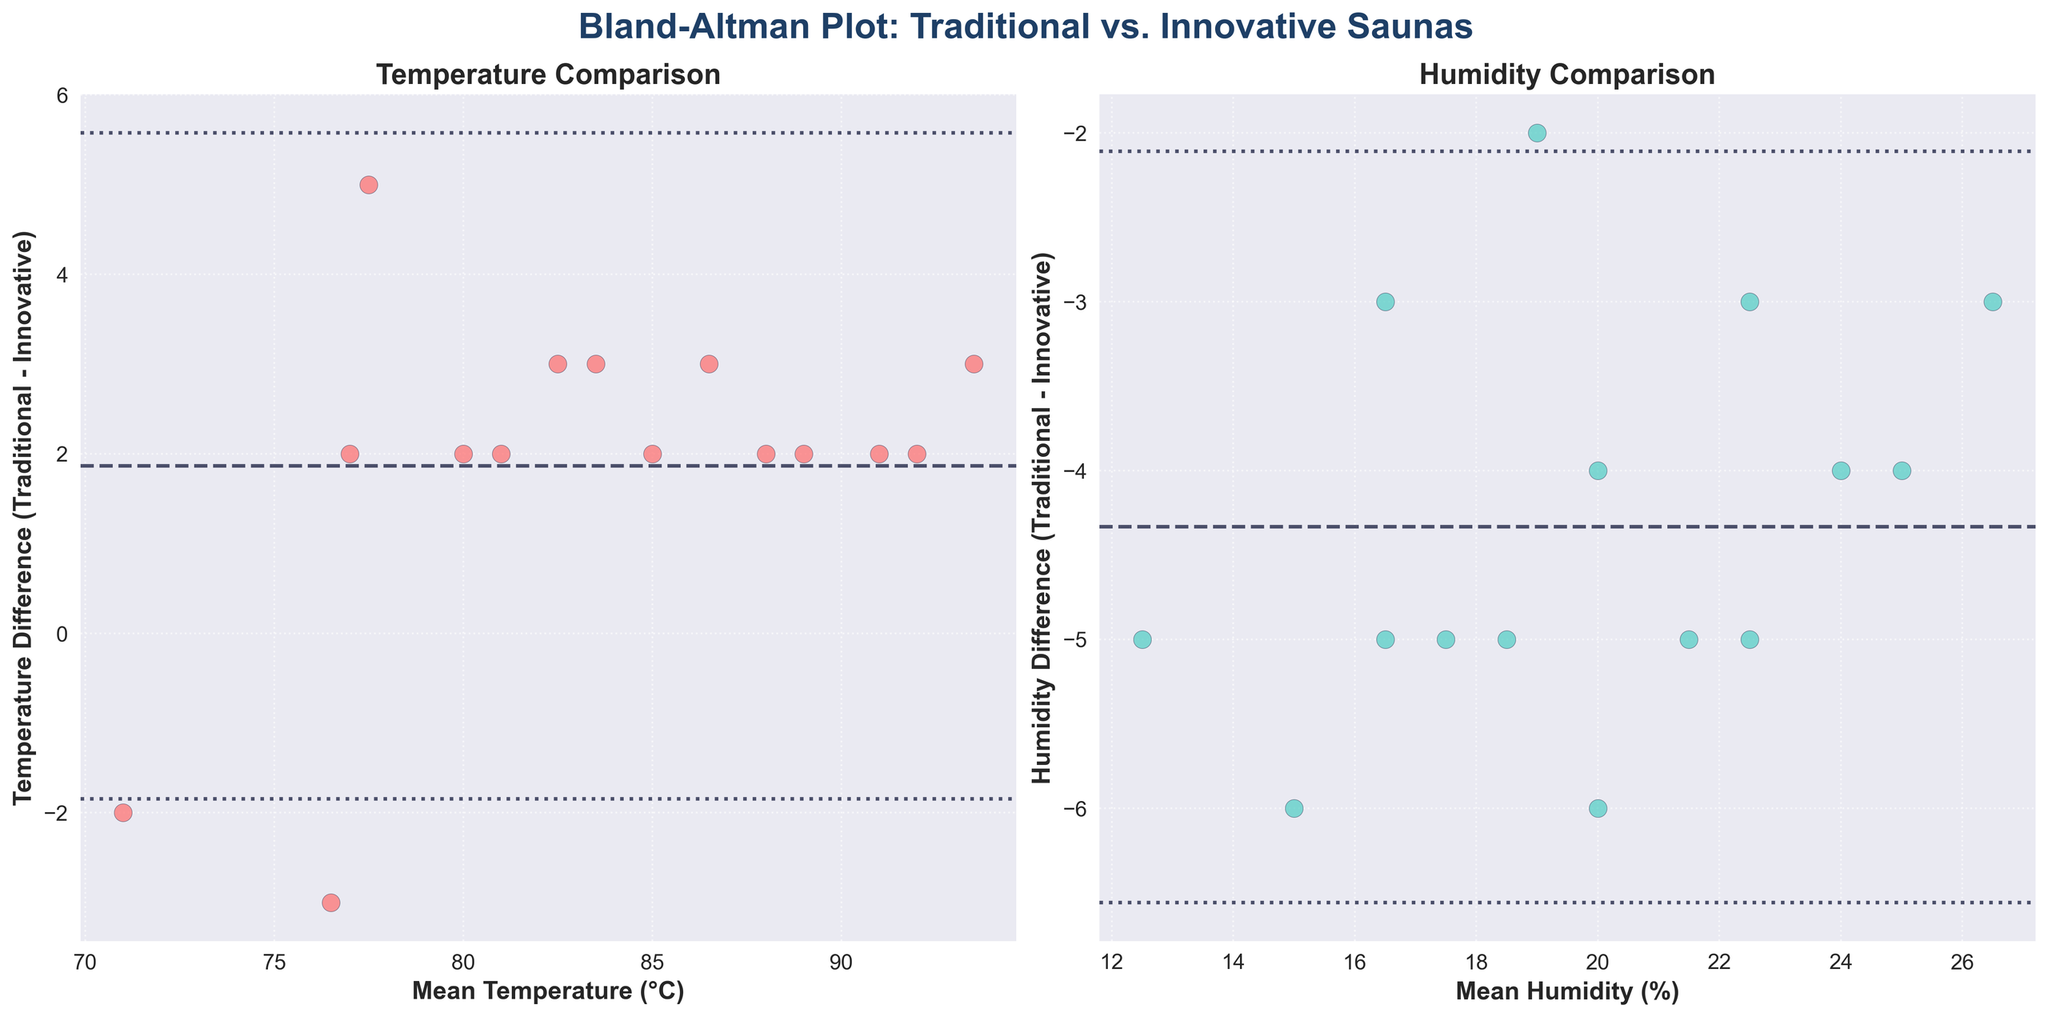What is the title of the figure? The title of the figure is displayed at the top in bold and larger font. It shows 'Bland-Altman Plot: Traditional vs. Innovative Saunas'.
Answer: Bland-Altman Plot: Traditional vs. Innovative Saunas What does the x-axis represent in the temperature plot? The x-axis label in the temperature plot indicates it represents the 'Mean Temperature (°C)'. This shows that the x-axis displays the average temperature of the traditional and innovative saunas.
Answer: Mean Temperature (°C) What color are the data points in the humidity comparison plot? The color of the data points in the humidity comparison plot is visible in the figure. The points are colored in a shade of turquoise.
Answer: Turquoise How many data points are represented in the figure? By counting the data points on either the temperature or humidity plot, one can see there are 15 points represented in each plot.
Answer: 15 What is the mean difference in temperature between traditional and innovative saunas? Locate the dashed horizontal line in the temperature plot. This line represents the mean difference, which can be read off the y-axis.
Answer: Approximately 2.53°C What is the range of the mean humidity values in the humidity plot? The range of the mean humidity values can be calculated by looking at the x-axis of the humidity plot and identifying the minimum and maximum values. The minimum is 14.5 and the maximum is around 26.5.
Answer: 14.5% to 26.5% Which plot shows a larger mean difference, temperature or humidity? Compare the positions of the dashed horizontal lines in both the temperature and humidity plots. The distance from y=0 to the dashed line is greater in the humidity plot.
Answer: Humidity plot What are the upper and lower limits of agreement in the temperature plot? Identify the dotted horizontal lines in the temperature plot. The upper limit is the mean difference plus 1.96 times the standard deviation, and the lower limit is the mean minus 1.96 times the standard deviation. These lines are near 6.94 and -1.88, respectively.
Answer: Approximately 6.94 and -1.88 Is there a visible trend in the difference in humidity as mean humidity increases? Observe the pattern of the data points in the humidity plot. If the points tend to rise or fall as the mean humidity increases, there is a trend. They tend to stay level, indicating no clear trend.
Answer: No clear trend 